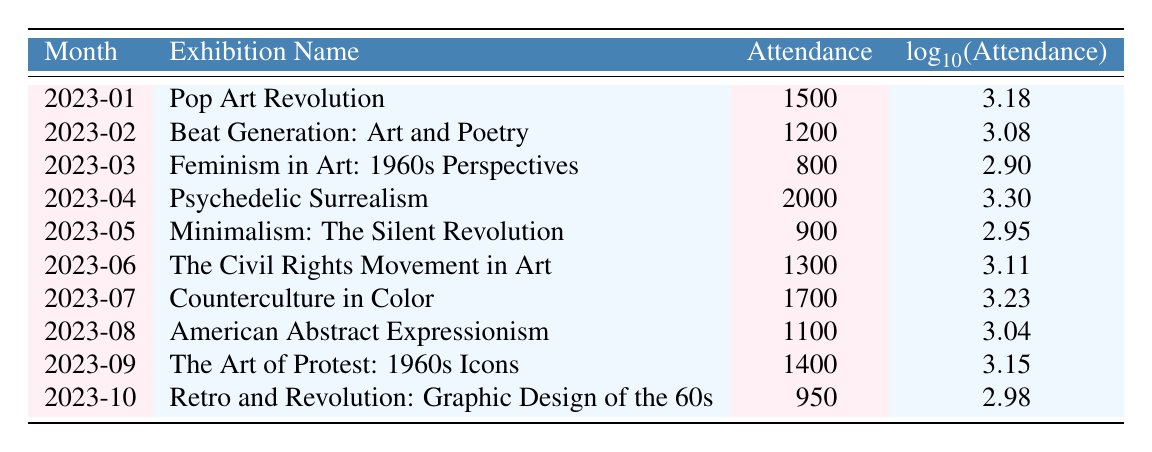What was the attendance at the "Feminism in Art: 1960s Perspectives" exhibition? The table lists the exhibition "Feminism in Art: 1960s Perspectives" under the month of March 2023, and indicates that its attendance was 800.
Answer: 800 Which exhibition had the highest attendance? Looking through the attendance figures in the table, "Psychedelic Surrealism" had the highest attendance of 2000, recorded in April 2023.
Answer: 2000 What is the average attendance for all exhibitions listed? To find the average attendance, sum all the attendance values: 1500 + 1200 + 800 + 2000 + 900 + 1300 + 1700 + 1100 + 1400 + 950 = 11850. Since there are 10 exhibitions, the average is 11850 / 10 = 1185.
Answer: 1185 Was the attendance for "Pop Art Revolution" greater than that for "Beat Generation: Art and Poetry"? The attendance for "Pop Art Revolution" is 1500, while "Beat Generation: Art and Poetry" has an attendance of 1200. Since 1500 is greater than 1200, the statement is true.
Answer: Yes What was the difference in attendance between the exhibition with the lowest and the highest attendance? The lowest attendance is from "Feminism in Art: 1960s Perspectives" with 800, and the highest is "Psychedelic Surrealism" with 2000. The difference is 2000 - 800 = 1200.
Answer: 1200 How many exhibitions had an attendance of over 1000? By examining the table, the exhibitions with attendance over 1000 are: "Pop Art Revolution" (1500), "Psychedelic Surrealism" (2000), "The Civil Rights Movement in Art" (1300), "Counterculture in Color" (1700), and "The Art of Protest: 1960s Icons" (1400). This totals up to 5 exhibitions.
Answer: 5 Which exhibition had an attendance closer to the average attendance? The average attendance is 1185. The attendance values close to that are "The Civil Rights Movement in Art" with 1300 (difference of 115) and "Counterculture in Color" with 1700 (difference of 515). Therefore, "The Civil Rights Movement in Art" is closer to the average.
Answer: The Civil Rights Movement in Art Is the logarithm of attendance for "American Abstract Expressionism" greater than that for "Minimum: The Silent Revolution"? The logarithm for "American Abstract Expressionism" is 3.04, and for "Minimalism: The Silent Revolution" it is 2.95. Since 3.04 is greater than 2.95, the statement is true.
Answer: Yes What was the total attendance for the exhibitions held from January to June? The total attendance from January to June can be calculated by adding the attendance figures: 1500 + 1200 + 800 + 2000 + 900 + 1300 = 7900.
Answer: 7900 